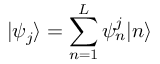Convert formula to latex. <formula><loc_0><loc_0><loc_500><loc_500>| \psi _ { j } \rangle = \sum _ { n = 1 } ^ { L } \psi _ { n } ^ { j } | n \rangle</formula> 